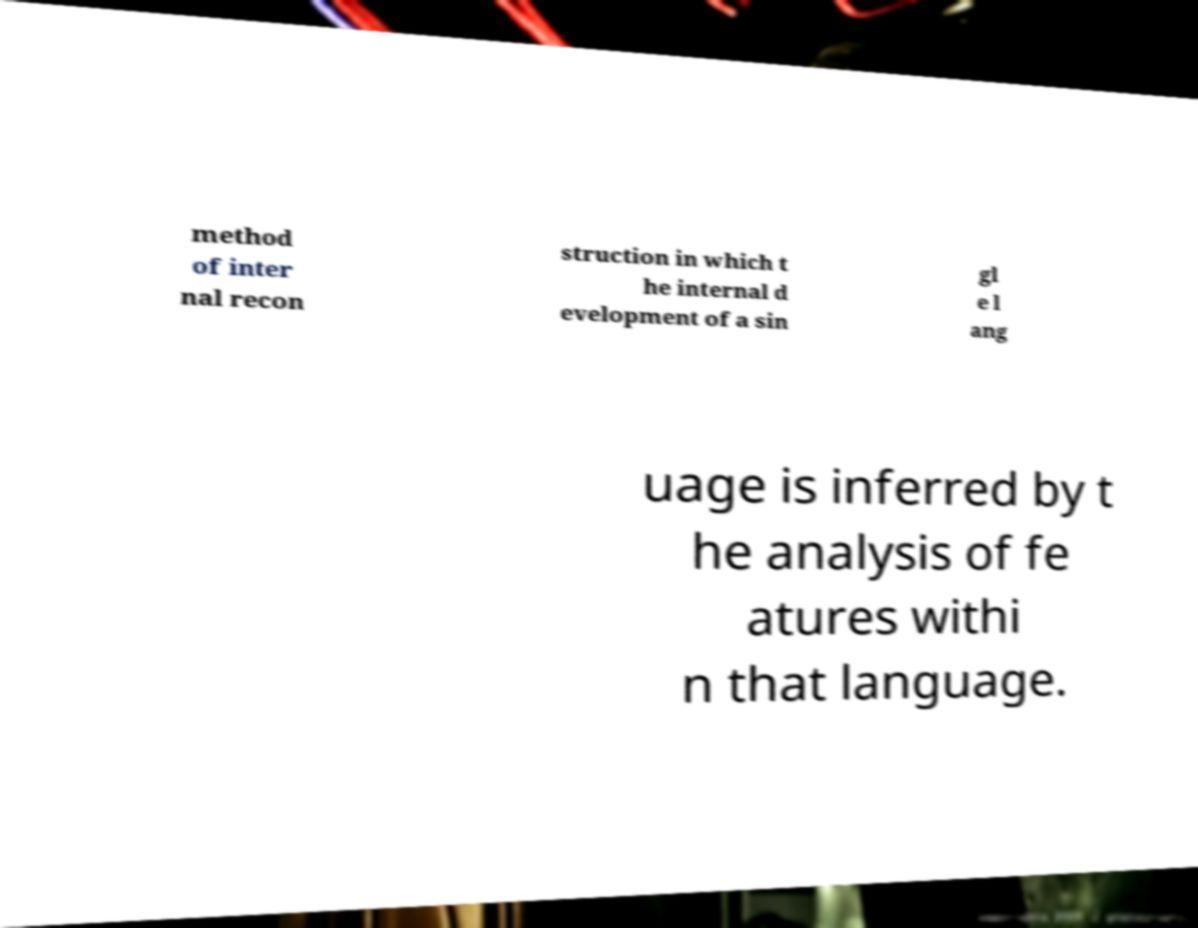Could you extract and type out the text from this image? method of inter nal recon struction in which t he internal d evelopment of a sin gl e l ang uage is inferred by t he analysis of fe atures withi n that language. 